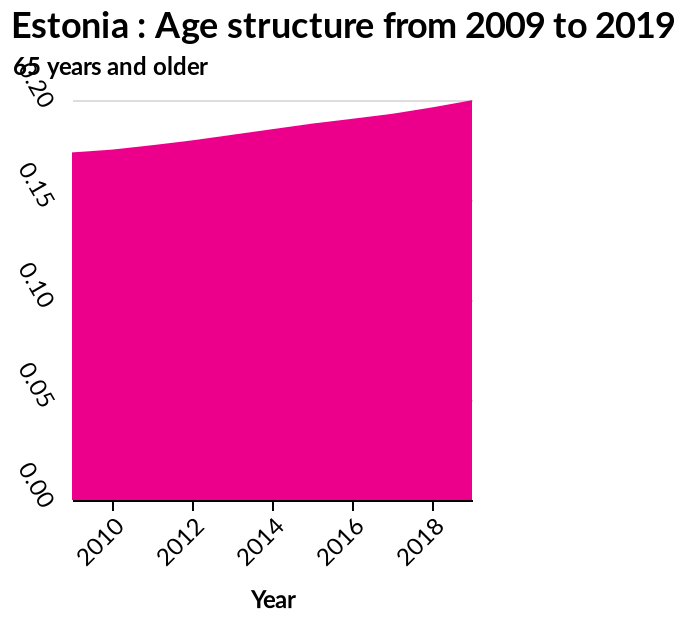<image>
How does the age structure change over time? The age structure increases as time progresses. Offer a thorough analysis of the image. As time progresses the trend of age increases. The age structure is highest in 2018. 